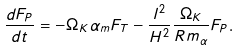Convert formula to latex. <formula><loc_0><loc_0><loc_500><loc_500>\frac { d F _ { P } } { d t } = - \Omega _ { K } \alpha _ { m } F _ { T } - \frac { l ^ { 2 } } { H ^ { 2 } } \frac { \Omega _ { K } } { R m _ { \alpha } } F _ { P } .</formula> 